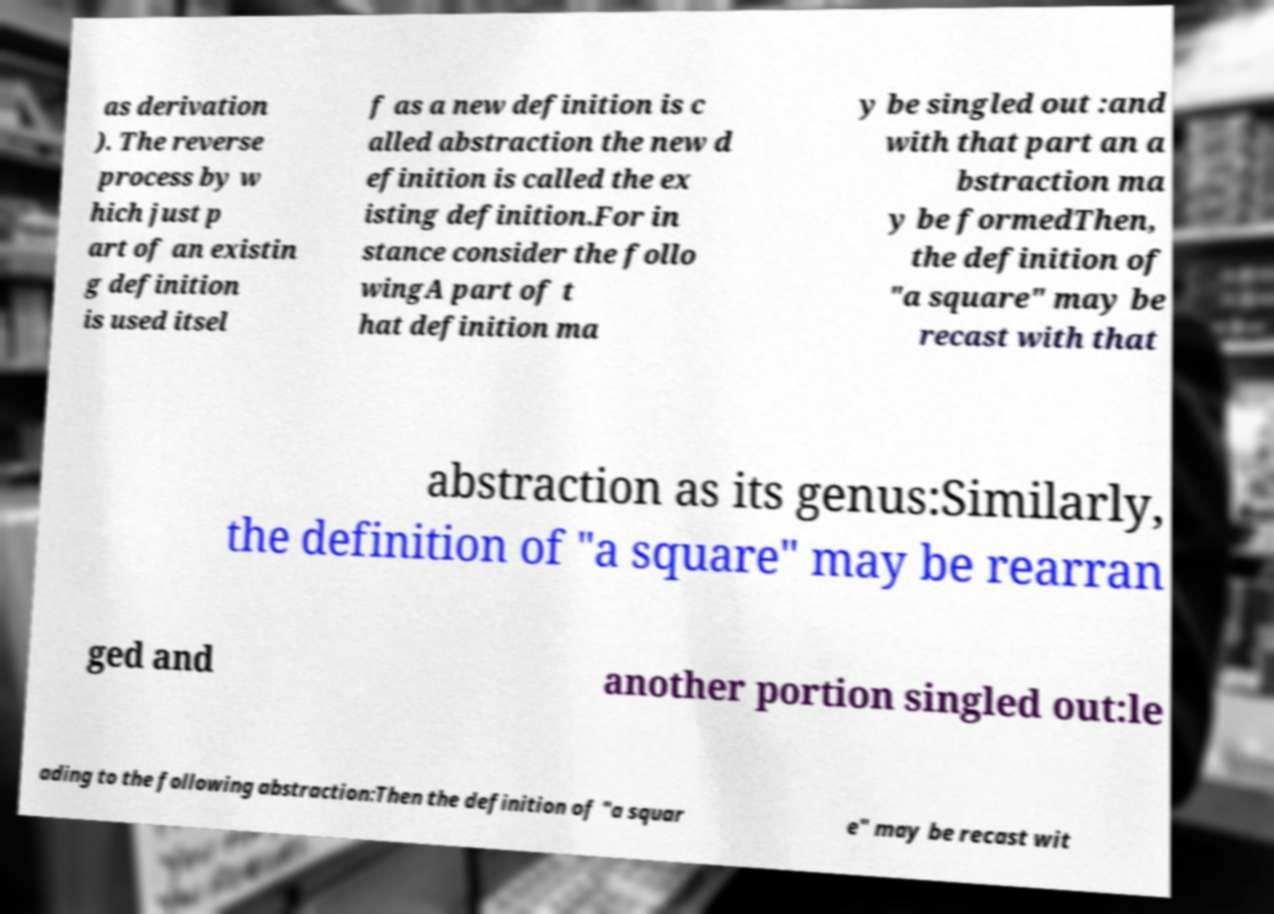Please identify and transcribe the text found in this image. as derivation ). The reverse process by w hich just p art of an existin g definition is used itsel f as a new definition is c alled abstraction the new d efinition is called the ex isting definition.For in stance consider the follo wingA part of t hat definition ma y be singled out :and with that part an a bstraction ma y be formedThen, the definition of "a square" may be recast with that abstraction as its genus:Similarly, the definition of "a square" may be rearran ged and another portion singled out:le ading to the following abstraction:Then the definition of "a squar e" may be recast wit 